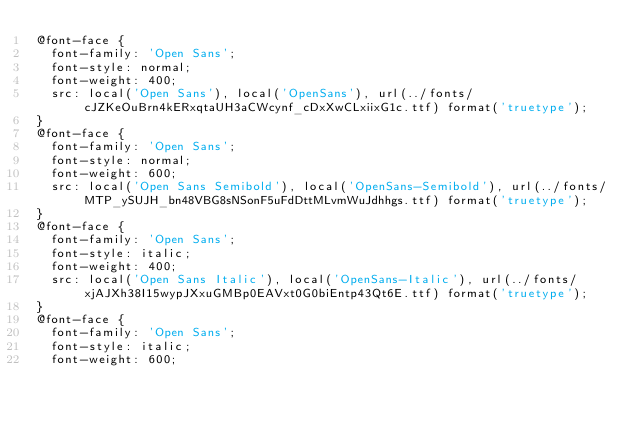Convert code to text. <code><loc_0><loc_0><loc_500><loc_500><_CSS_>@font-face {
  font-family: 'Open Sans';
  font-style: normal;
  font-weight: 400;
  src: local('Open Sans'), local('OpenSans'), url(../fonts/cJZKeOuBrn4kERxqtaUH3aCWcynf_cDxXwCLxiixG1c.ttf) format('truetype');
}
@font-face {
  font-family: 'Open Sans';
  font-style: normal;
  font-weight: 600;
  src: local('Open Sans Semibold'), local('OpenSans-Semibold'), url(../fonts/MTP_ySUJH_bn48VBG8sNSonF5uFdDttMLvmWuJdhhgs.ttf) format('truetype');
}
@font-face {
  font-family: 'Open Sans';
  font-style: italic;
  font-weight: 400;
  src: local('Open Sans Italic'), local('OpenSans-Italic'), url(../fonts/xjAJXh38I15wypJXxuGMBp0EAVxt0G0biEntp43Qt6E.ttf) format('truetype');
}
@font-face {
  font-family: 'Open Sans';
  font-style: italic;
  font-weight: 600;</code> 